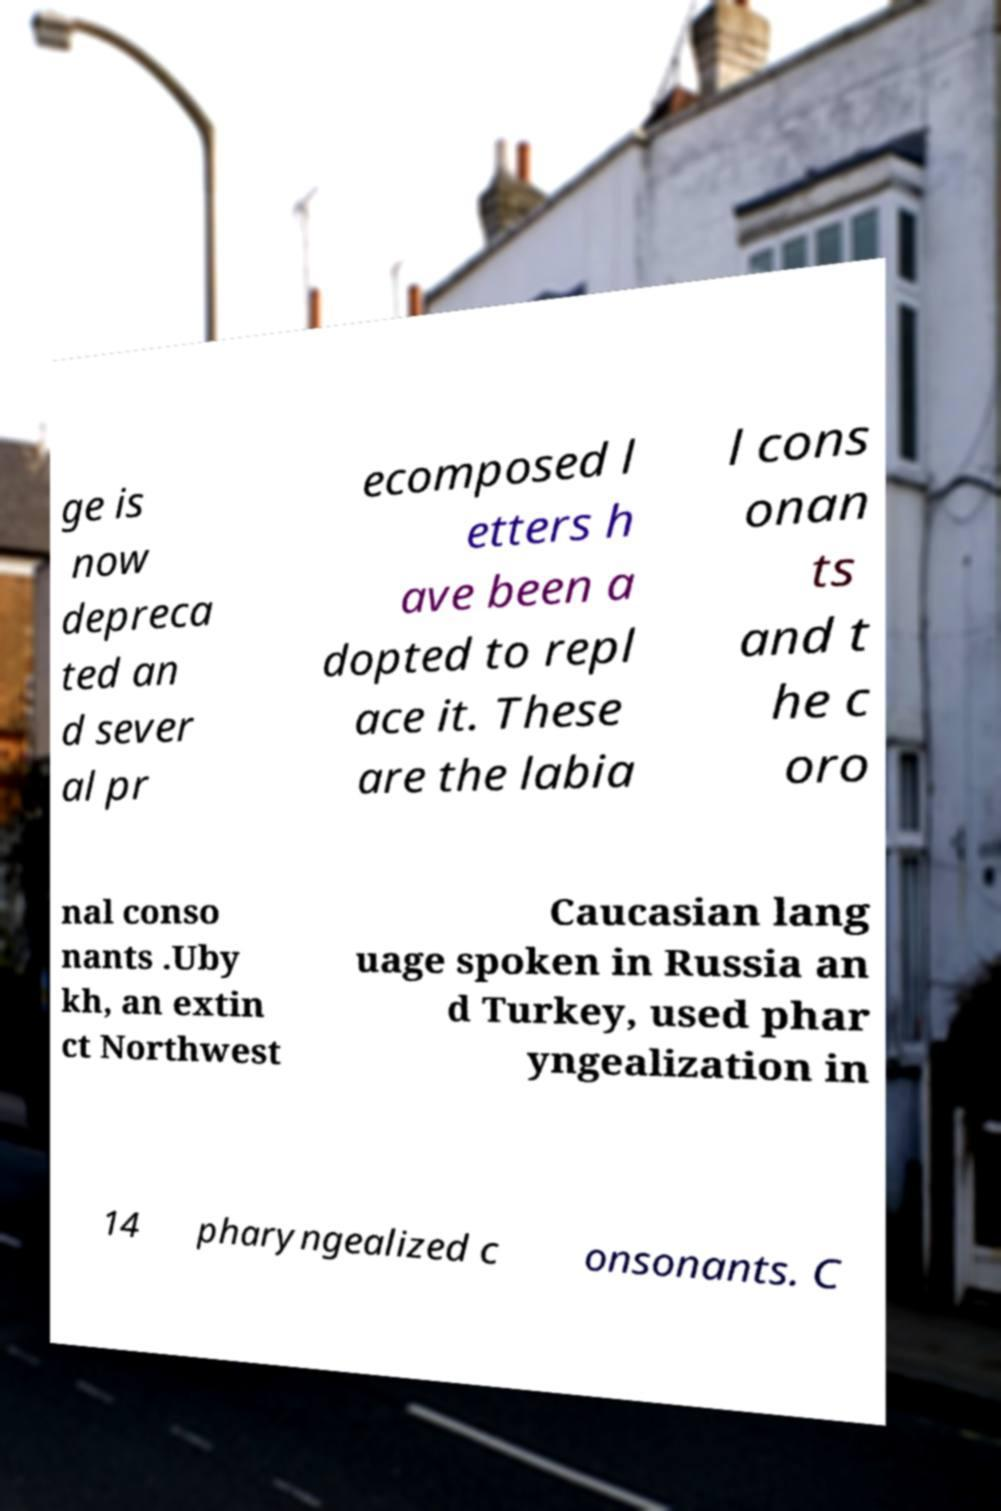Could you assist in decoding the text presented in this image and type it out clearly? ge is now depreca ted an d sever al pr ecomposed l etters h ave been a dopted to repl ace it. These are the labia l cons onan ts and t he c oro nal conso nants .Uby kh, an extin ct Northwest Caucasian lang uage spoken in Russia an d Turkey, used phar yngealization in 14 pharyngealized c onsonants. C 